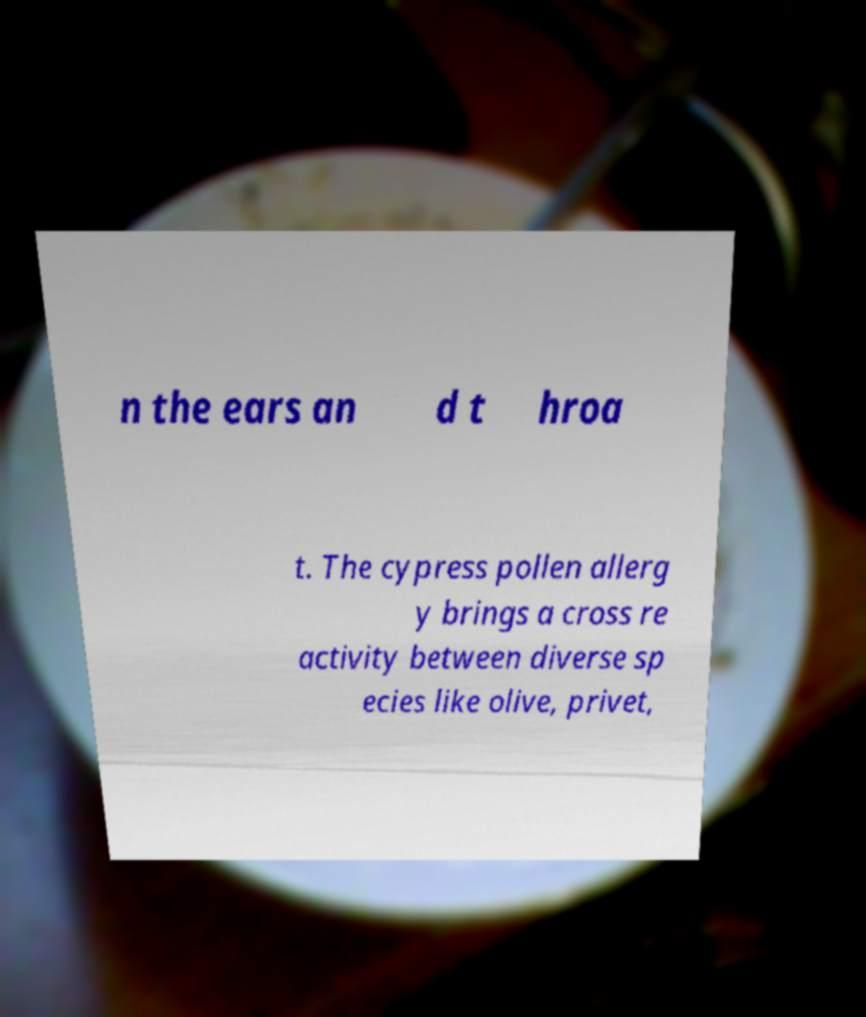Can you accurately transcribe the text from the provided image for me? n the ears an d t hroa t. The cypress pollen allerg y brings a cross re activity between diverse sp ecies like olive, privet, 